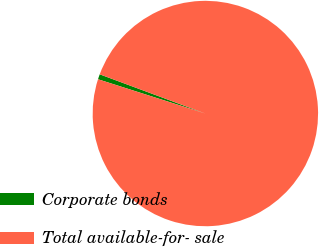Convert chart to OTSL. <chart><loc_0><loc_0><loc_500><loc_500><pie_chart><fcel>Corporate bonds<fcel>Total available-for- sale<nl><fcel>0.74%<fcel>99.26%<nl></chart> 